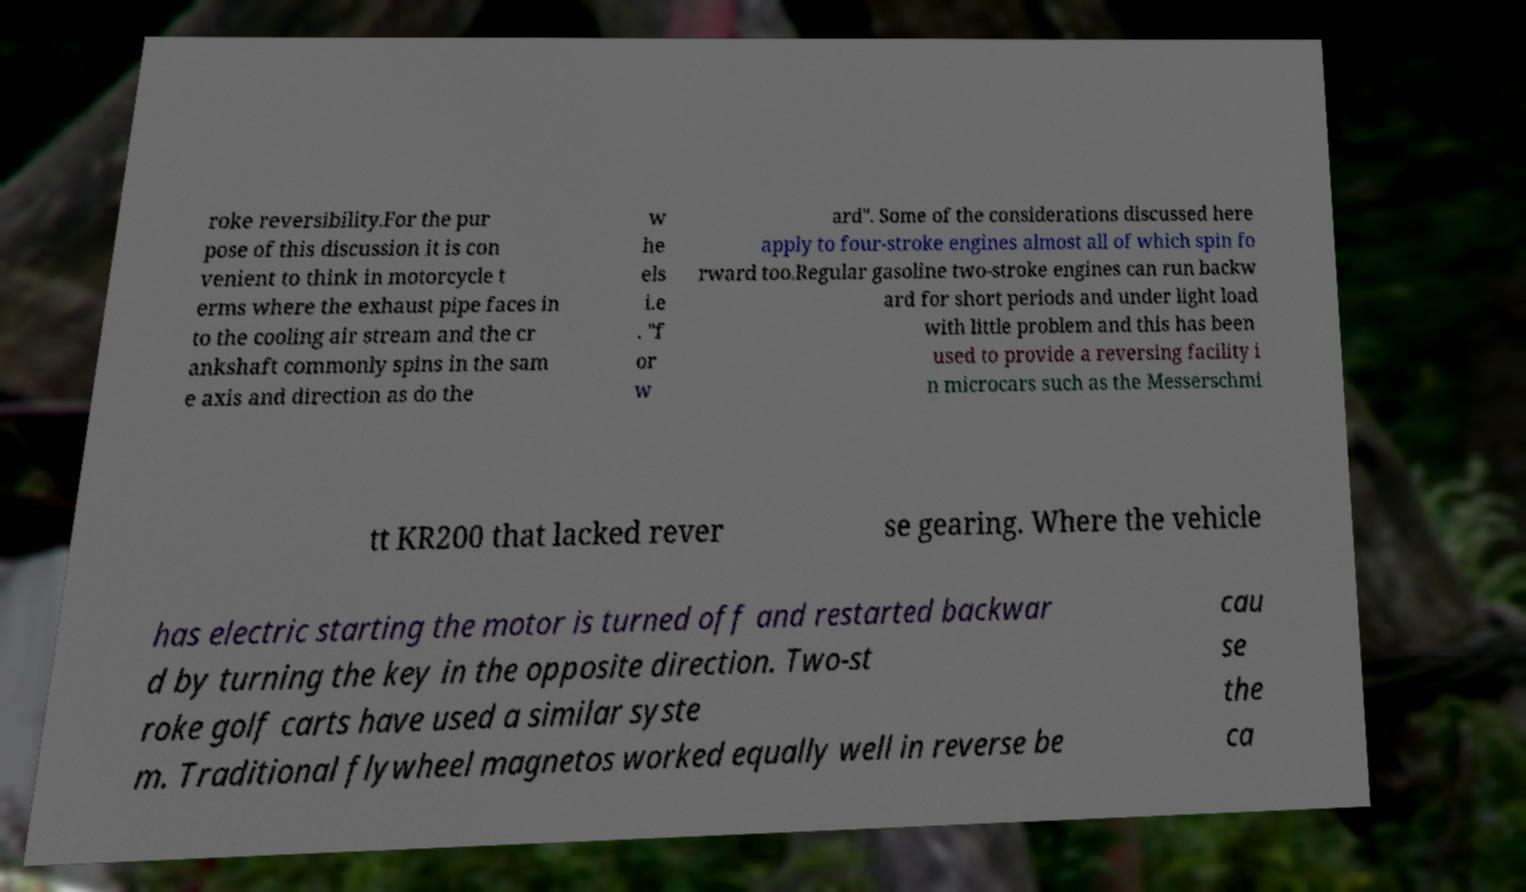Please identify and transcribe the text found in this image. roke reversibility.For the pur pose of this discussion it is con venient to think in motorcycle t erms where the exhaust pipe faces in to the cooling air stream and the cr ankshaft commonly spins in the sam e axis and direction as do the w he els i.e . "f or w ard". Some of the considerations discussed here apply to four-stroke engines almost all of which spin fo rward too.Regular gasoline two-stroke engines can run backw ard for short periods and under light load with little problem and this has been used to provide a reversing facility i n microcars such as the Messerschmi tt KR200 that lacked rever se gearing. Where the vehicle has electric starting the motor is turned off and restarted backwar d by turning the key in the opposite direction. Two-st roke golf carts have used a similar syste m. Traditional flywheel magnetos worked equally well in reverse be cau se the ca 